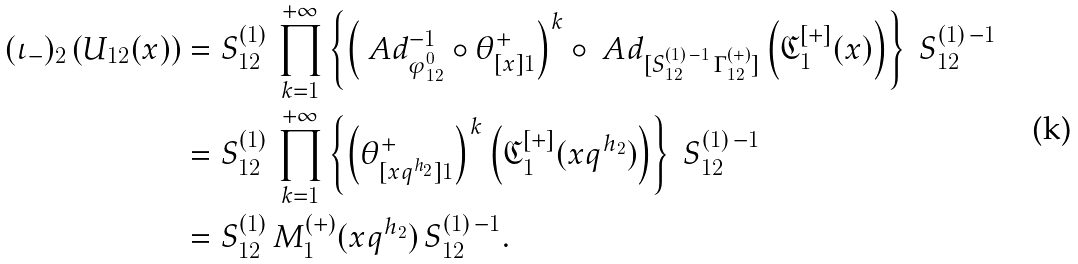Convert formula to latex. <formula><loc_0><loc_0><loc_500><loc_500>( \iota _ { - } ) _ { 2 } \left ( U _ { 1 2 } ( x ) \right ) & = S ^ { ( 1 ) } _ { 1 2 } \, \prod _ { k = 1 } ^ { + \infty } \left \{ \left ( \ A d ^ { - 1 } _ { \varphi _ { 1 2 } ^ { 0 } } \circ \theta ^ { + } _ { [ x ] 1 } \right ) ^ { k } \circ \ A d _ { [ S ^ { ( 1 ) \, - 1 } _ { 1 2 } \, \Gamma _ { 1 2 } ^ { ( + ) } ] } \left ( { \mathfrak C } ^ { [ + ] } _ { 1 } ( x ) \right ) \right \} \ S ^ { ( 1 ) \, - 1 } _ { 1 2 } \\ & = S ^ { ( 1 ) } _ { 1 2 } \, \prod _ { k = 1 } ^ { + \infty } \left \{ \left ( \theta ^ { + } _ { [ x q ^ { h _ { 2 } } ] 1 } \right ) ^ { k } \left ( { \mathfrak C } ^ { [ + ] } _ { 1 } ( x q ^ { h _ { 2 } } ) \right ) \right \} \ S ^ { ( 1 ) \, - 1 } _ { 1 2 } \\ & = S ^ { ( 1 ) } _ { 1 2 } \, M _ { 1 } ^ { ( + ) } ( x q ^ { h _ { 2 } } ) \, S ^ { ( 1 ) \, - 1 } _ { 1 2 } .</formula> 